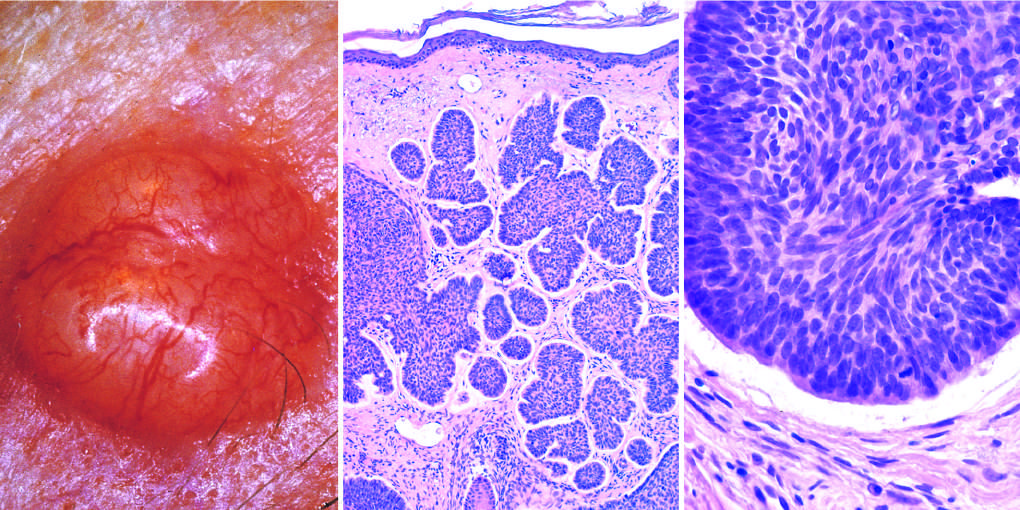s tumor composed of nests of basaloid cells infiltrating a fibrotic stroma?
Answer the question using a single word or phrase. Yes 